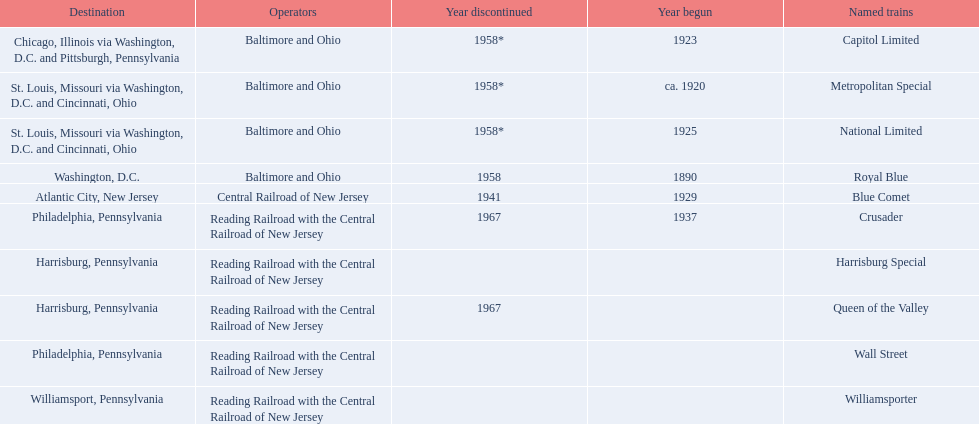What are the destinations of the central railroad of new jersey terminal? Chicago, Illinois via Washington, D.C. and Pittsburgh, Pennsylvania, St. Louis, Missouri via Washington, D.C. and Cincinnati, Ohio, St. Louis, Missouri via Washington, D.C. and Cincinnati, Ohio, Washington, D.C., Atlantic City, New Jersey, Philadelphia, Pennsylvania, Harrisburg, Pennsylvania, Harrisburg, Pennsylvania, Philadelphia, Pennsylvania, Williamsport, Pennsylvania. Which of these destinations is at the top of the list? Chicago, Illinois via Washington, D.C. and Pittsburgh, Pennsylvania. 